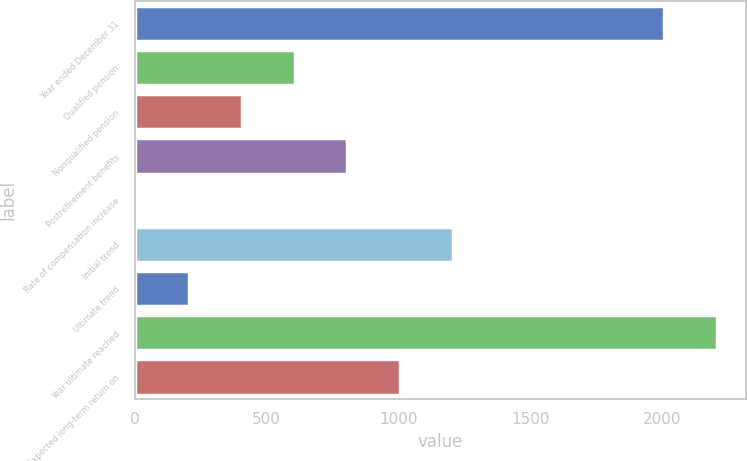Convert chart. <chart><loc_0><loc_0><loc_500><loc_500><bar_chart><fcel>Year ended December 31<fcel>Qualified pension<fcel>Nonqualified pension<fcel>Postretirement benefits<fcel>Rate of compensation increase<fcel>Initial trend<fcel>Ultimate trend<fcel>Year ultimate reached<fcel>Expected long-term return on<nl><fcel>2006<fcel>606.1<fcel>405.4<fcel>806.8<fcel>4<fcel>1208.2<fcel>204.7<fcel>2206.7<fcel>1007.5<nl></chart> 